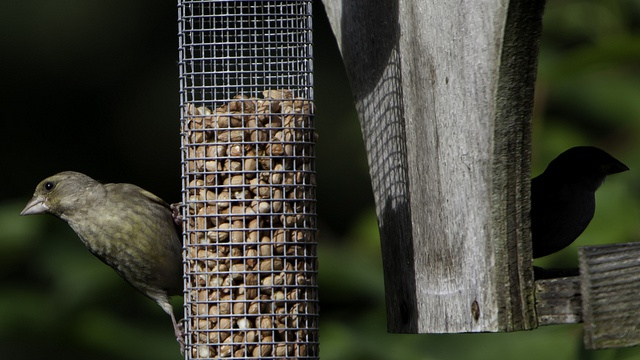Describe the objects in this image and their specific colors. I can see bird in black, gray, and darkgreen tones and bird in black and darkgreen tones in this image. 